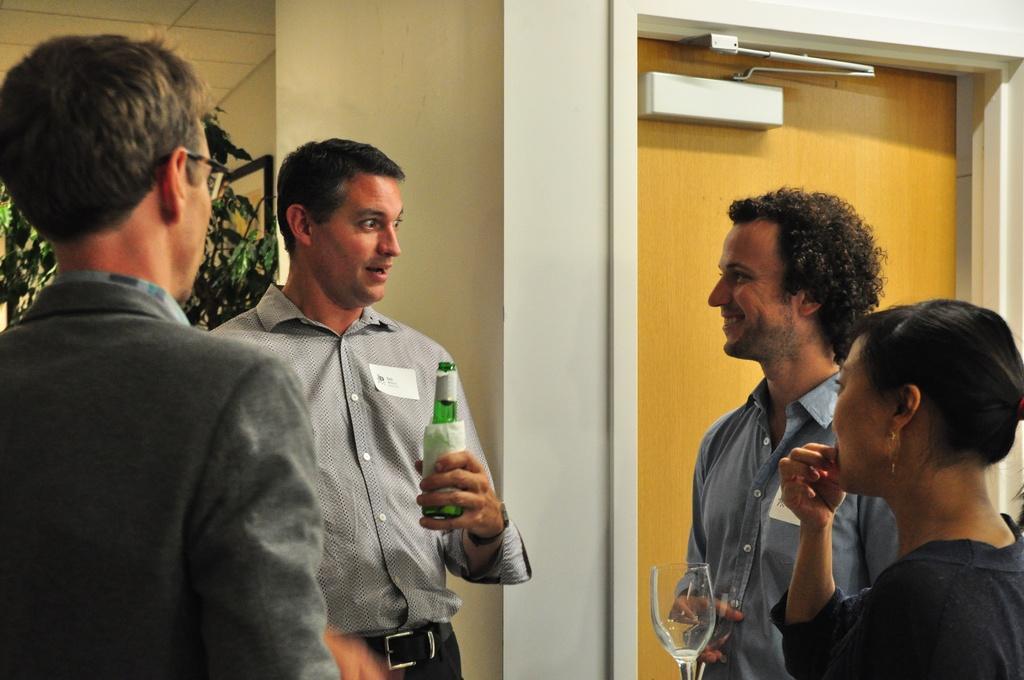Can you describe this image briefly? In this picture we can see four persons standing here, this man is holding a bottle, there is a glass here, in the background there is a door, we can see a wall here, on the left side there is a plant. 